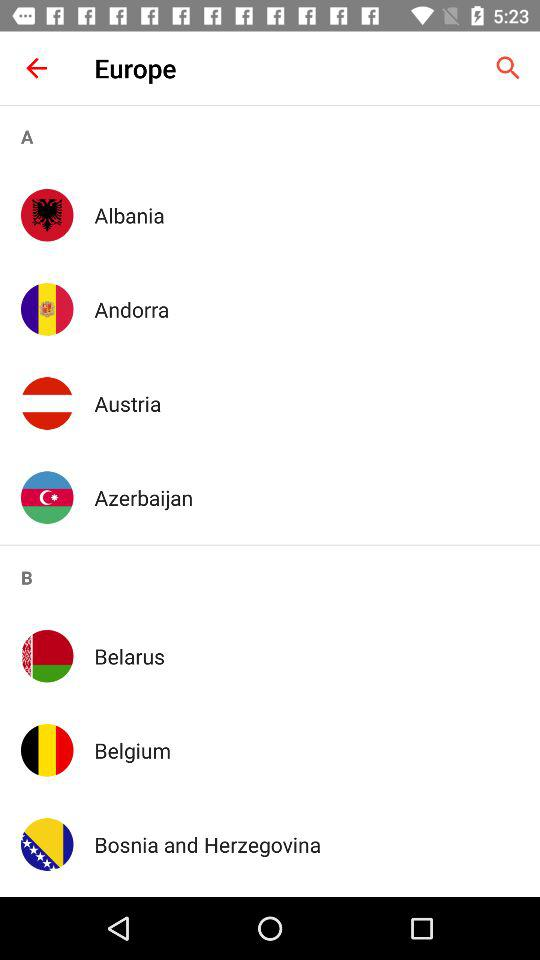Which region is selected?
When the provided information is insufficient, respond with <no answer>. <no answer> 